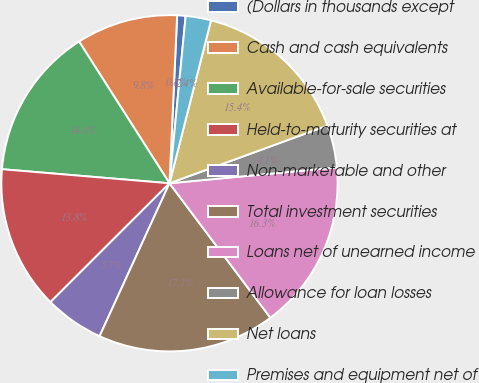Convert chart to OTSL. <chart><loc_0><loc_0><loc_500><loc_500><pie_chart><fcel>(Dollars in thousands except<fcel>Cash and cash equivalents<fcel>Available-for-sale securities<fcel>Held-to-maturity securities at<fcel>Non-marketable and other<fcel>Total investment securities<fcel>Loans net of unearned income<fcel>Allowance for loan losses<fcel>Net loans<fcel>Premises and equipment net of<nl><fcel>0.81%<fcel>9.76%<fcel>14.63%<fcel>13.82%<fcel>5.69%<fcel>17.07%<fcel>16.26%<fcel>4.07%<fcel>15.45%<fcel>2.44%<nl></chart> 